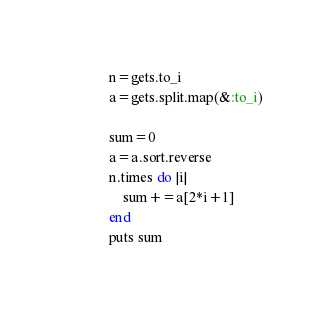<code> <loc_0><loc_0><loc_500><loc_500><_Ruby_>n=gets.to_i
a=gets.split.map(&:to_i)

sum=0
a=a.sort.reverse
n.times do |i|
    sum+=a[2*i+1]
end
puts sum
</code> 